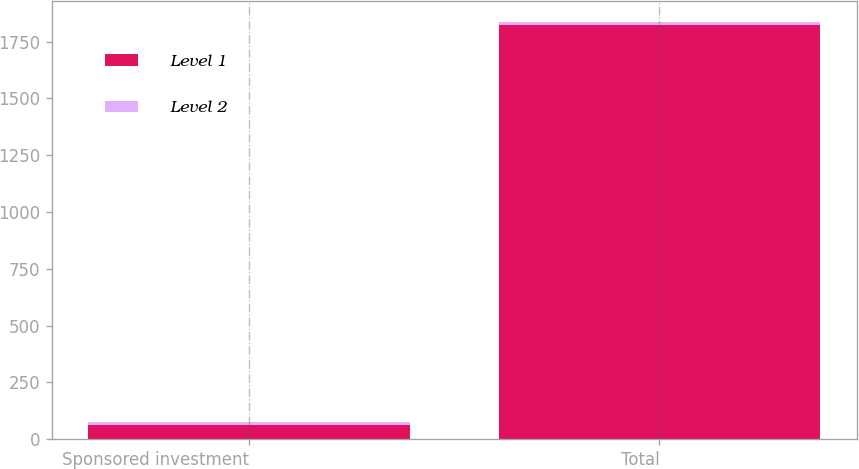<chart> <loc_0><loc_0><loc_500><loc_500><stacked_bar_chart><ecel><fcel>Sponsored investment<fcel>Total<nl><fcel>Level 1<fcel>60.3<fcel>1821.6<nl><fcel>Level 2<fcel>15.1<fcel>15.1<nl></chart> 